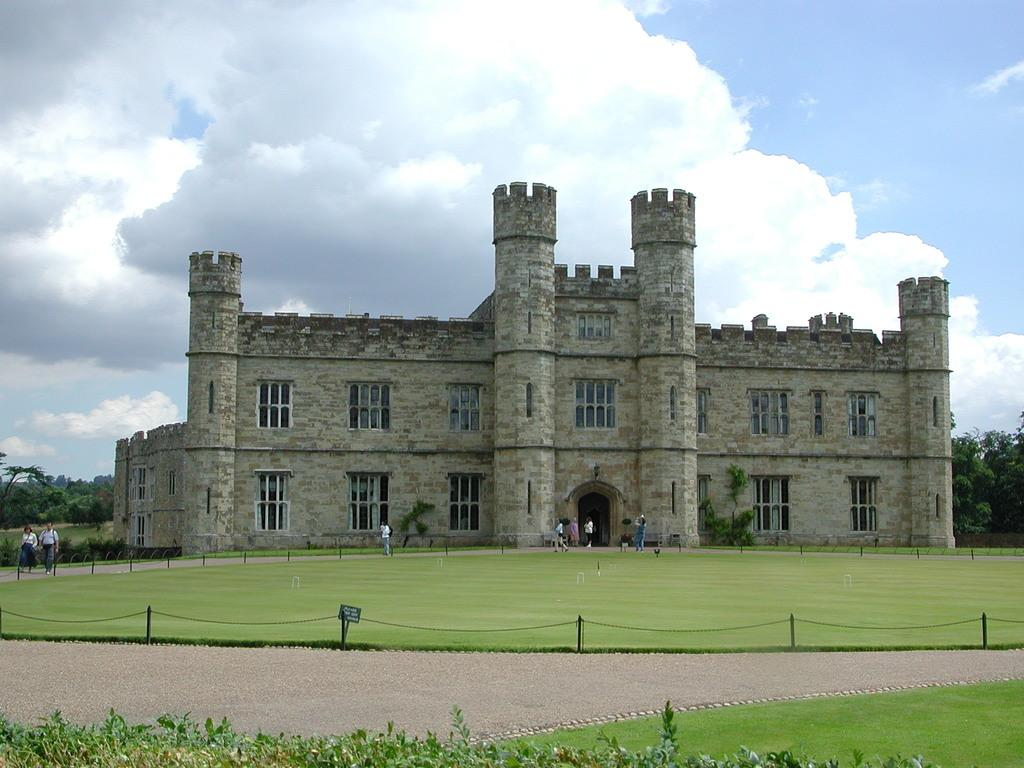What are the persons in the image doing? The persons in the image are walking. What can be seen in the background of the image? There is a building, trees, and the sky visible in the background of the image. What is the color of the building in the image? The building is gray in color. What is the color of the trees in the image? The trees are green in color. What colors are visible in the sky in the image? The sky has a combination of white and blue colors. What type of metal vessel can be seen being carried by the persons in the image? There is no metal vessel visible in the image; the persons are simply walking. What type of trousers are the persons wearing in the image? The image does not provide enough detail to determine the type of trousers the persons are wearing. 